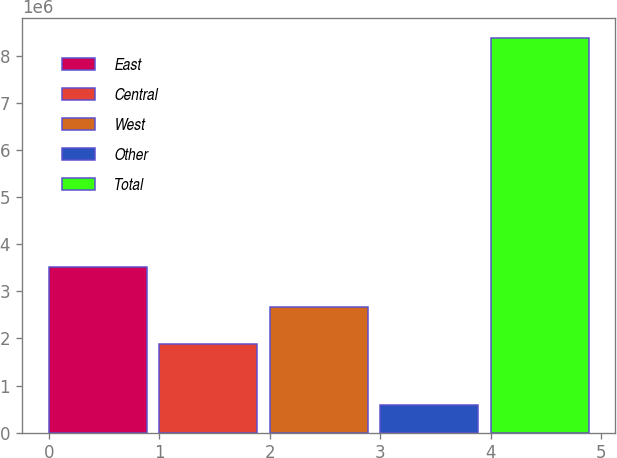Convert chart to OTSL. <chart><loc_0><loc_0><loc_500><loc_500><bar_chart><fcel>East<fcel>Central<fcel>West<fcel>Other<fcel>Total<nl><fcel>3.52761e+06<fcel>1.88813e+06<fcel>2.66804e+06<fcel>584435<fcel>8.38361e+06<nl></chart> 